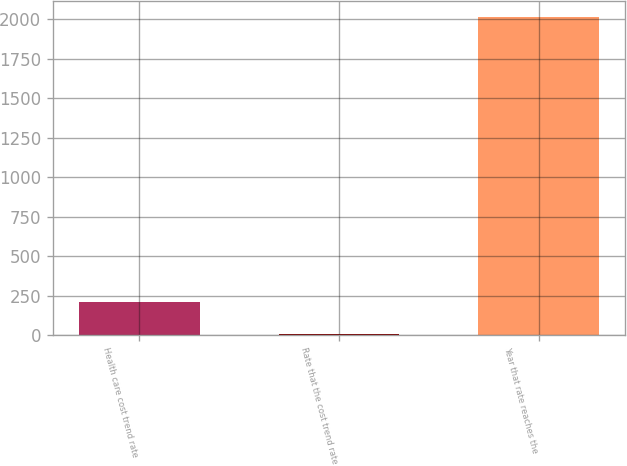Convert chart to OTSL. <chart><loc_0><loc_0><loc_500><loc_500><bar_chart><fcel>Health care cost trend rate<fcel>Rate that the cost trend rate<fcel>Year that rate reaches the<nl><fcel>206.1<fcel>5<fcel>2016<nl></chart> 